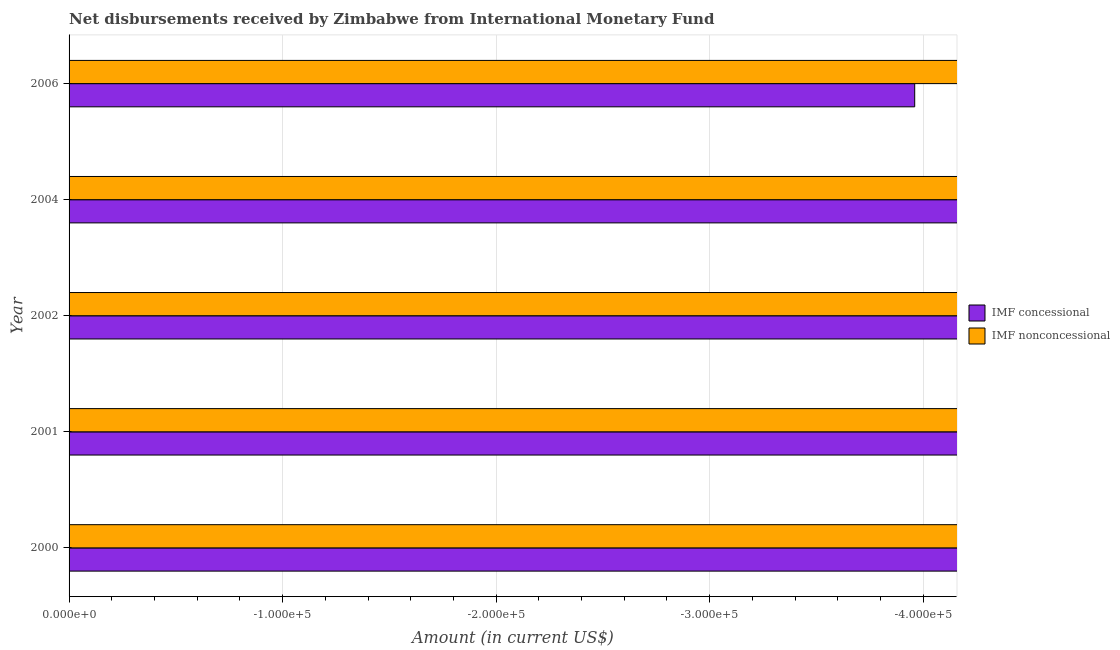How many different coloured bars are there?
Give a very brief answer. 0. Are the number of bars per tick equal to the number of legend labels?
Provide a succinct answer. No. Are the number of bars on each tick of the Y-axis equal?
Offer a very short reply. Yes. How many bars are there on the 1st tick from the top?
Provide a short and direct response. 0. In how many cases, is the number of bars for a given year not equal to the number of legend labels?
Your response must be concise. 5. What is the net non concessional disbursements from imf in 2006?
Your answer should be compact. 0. Across all years, what is the minimum net non concessional disbursements from imf?
Your answer should be very brief. 0. What is the total net concessional disbursements from imf in the graph?
Your answer should be very brief. 0. How many years are there in the graph?
Offer a very short reply. 5. Are the values on the major ticks of X-axis written in scientific E-notation?
Provide a succinct answer. Yes. Does the graph contain grids?
Ensure brevity in your answer.  Yes. Where does the legend appear in the graph?
Ensure brevity in your answer.  Center right. How are the legend labels stacked?
Keep it short and to the point. Vertical. What is the title of the graph?
Provide a succinct answer. Net disbursements received by Zimbabwe from International Monetary Fund. Does "Male population" appear as one of the legend labels in the graph?
Your answer should be very brief. No. What is the Amount (in current US$) in IMF nonconcessional in 2000?
Give a very brief answer. 0. What is the Amount (in current US$) of IMF nonconcessional in 2001?
Keep it short and to the point. 0. What is the Amount (in current US$) of IMF concessional in 2002?
Offer a terse response. 0. What is the Amount (in current US$) in IMF nonconcessional in 2006?
Your answer should be compact. 0. What is the total Amount (in current US$) of IMF concessional in the graph?
Provide a short and direct response. 0. What is the total Amount (in current US$) of IMF nonconcessional in the graph?
Keep it short and to the point. 0. What is the average Amount (in current US$) in IMF concessional per year?
Give a very brief answer. 0. What is the average Amount (in current US$) in IMF nonconcessional per year?
Give a very brief answer. 0. 